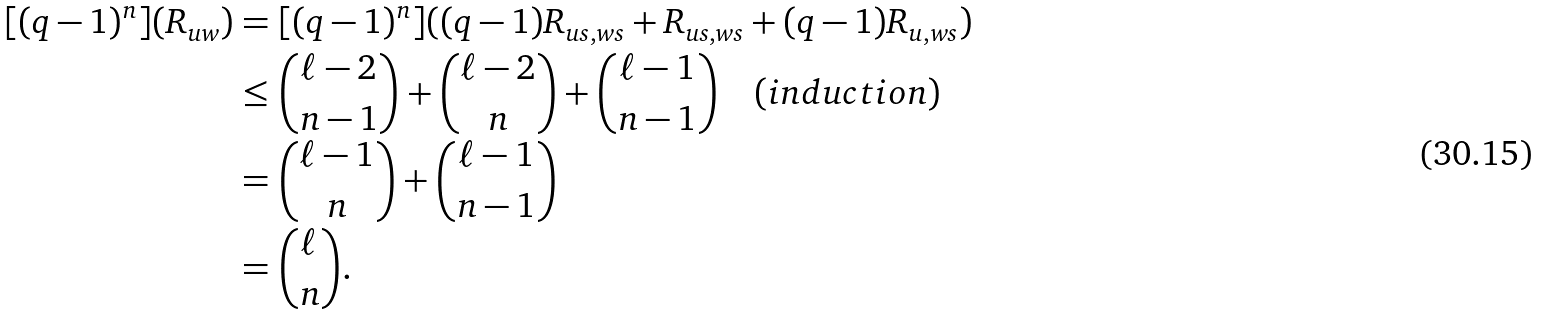<formula> <loc_0><loc_0><loc_500><loc_500>[ ( q - 1 ) ^ { n } ] ( R _ { u w } ) & = [ ( q - 1 ) ^ { n } ] ( ( q - 1 ) R _ { u s , w s } + R _ { u s , w s } + ( q - 1 ) R _ { u , w s } ) \\ & \leq \binom { \ell - 2 } { n - 1 } + \binom { \ell - 2 } { n } + \binom { \ell - 1 } { n - 1 } \quad ( i n d u c t i o n ) \\ & = \binom { \ell - 1 } { n } + \binom { \ell - 1 } { n - 1 } \\ & = \binom { \ell } { n } .</formula> 